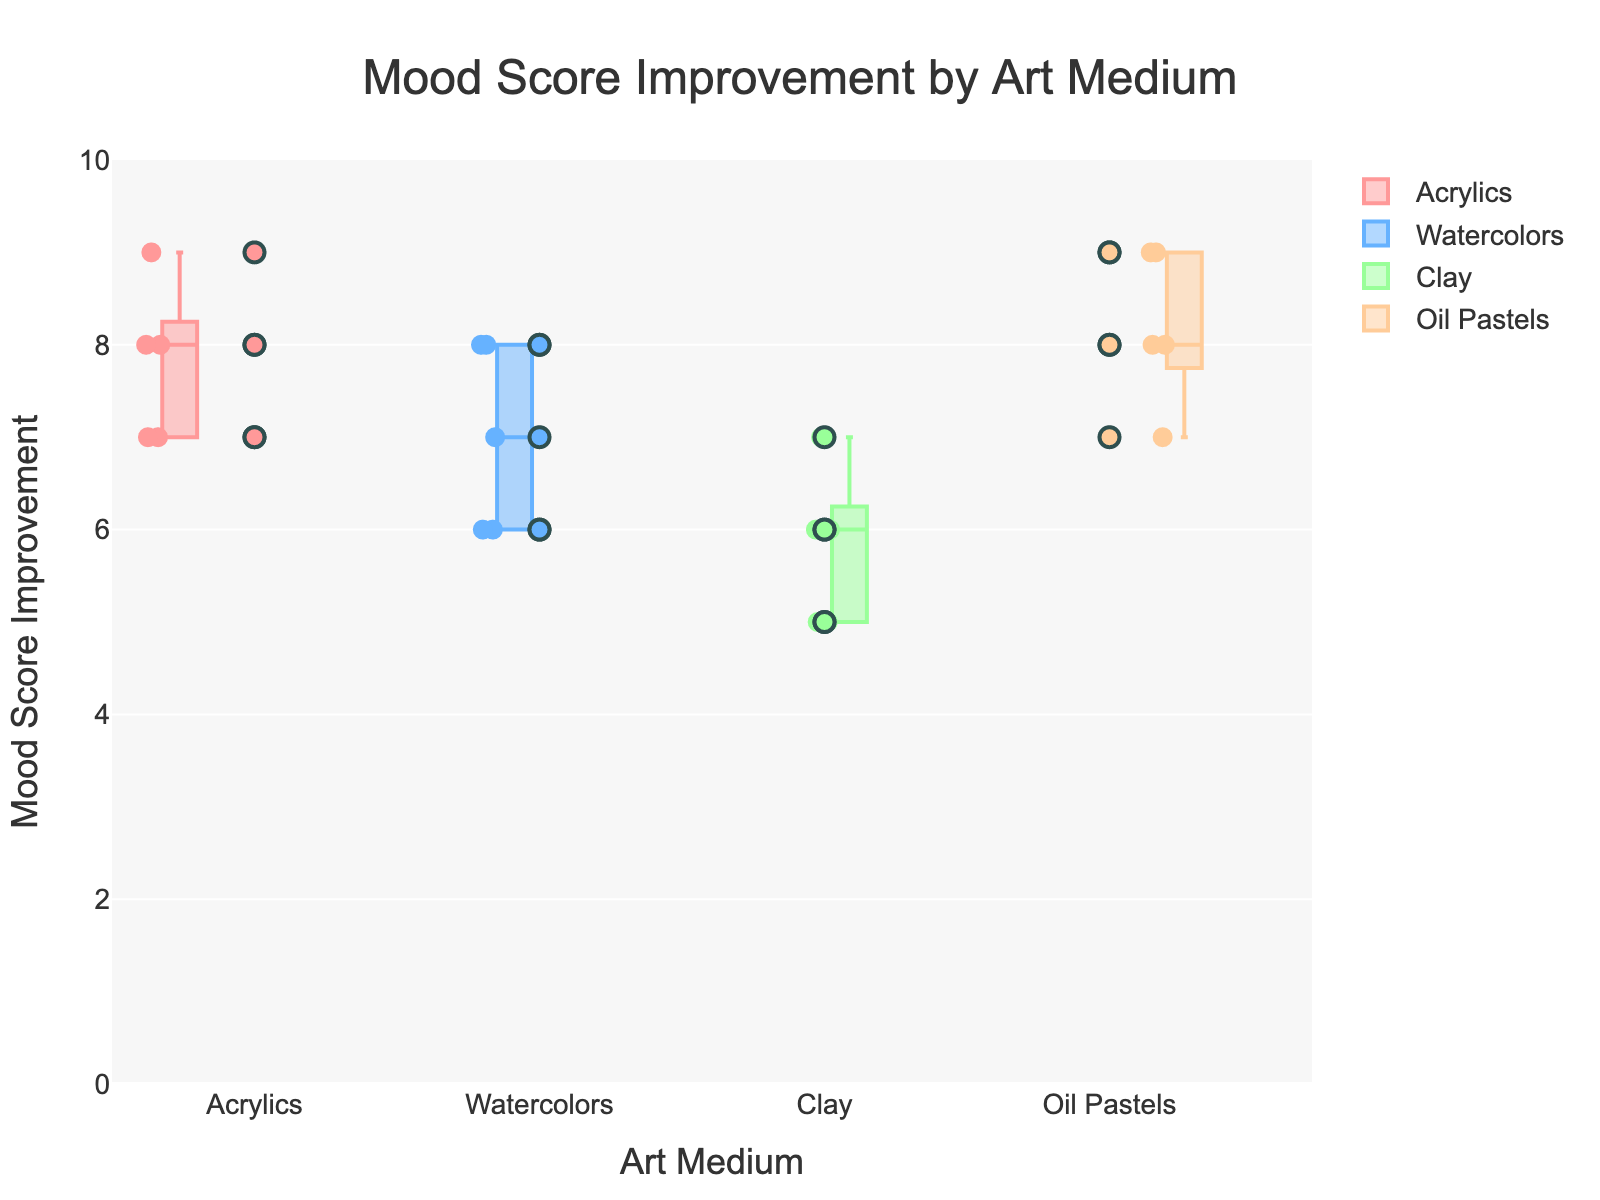What's the title of the figure? The title is located at the top center of the figure.
Answer: Mood Score Improvement by Art Medium What are the four art mediums shown in the figure? Look for the categories on the x-axis labels.
Answer: Acrylics, Watercolors, Clay, Oil Pastels Which medium has the highest upper whisker in the box plot? Identify the box plot with the highest range on the y-axis.
Answer: Oil Pastels How many scatter points are there for Acrylics? Count the individual scatter points for Acrylics in the figure.
Answer: 5 What is the median mood score improvement for Watercolors? Look for the middle line in the box plot for Watercolors.
Answer: 7 What is the interquartile range (IQR) for Clay? Calculate the difference between the upper quartile (top of the box) and the lower quartile (bottom of the box) of the Clay box plot.
Answer: 2 Which medium has the most consistent mood score improvements? Identify the box plot with the smallest IQR, representing more consistency.
Answer: Oil Pastels How does the mood score improvement for Clay compare to Acrylics? Compare the medians and ranges of the two box plots.
Answer: Generally lower and more variable for Clay Which medium shows the greatest variability in mood score improvements? Look for the box plot with the widest spread (range between whiskers).
Answer: Clay What is the difference between the highest mood score improvement for Watercolors and the lowest mood score improvement for Oil Pastels? Identify the highest point for Watercolors and the lowest point for Oil Pastels, then calculate the difference.
Answer: 2 